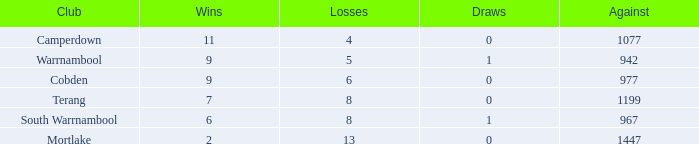What is the draw when the losses were more than 8 and less than 2 wins? None. 